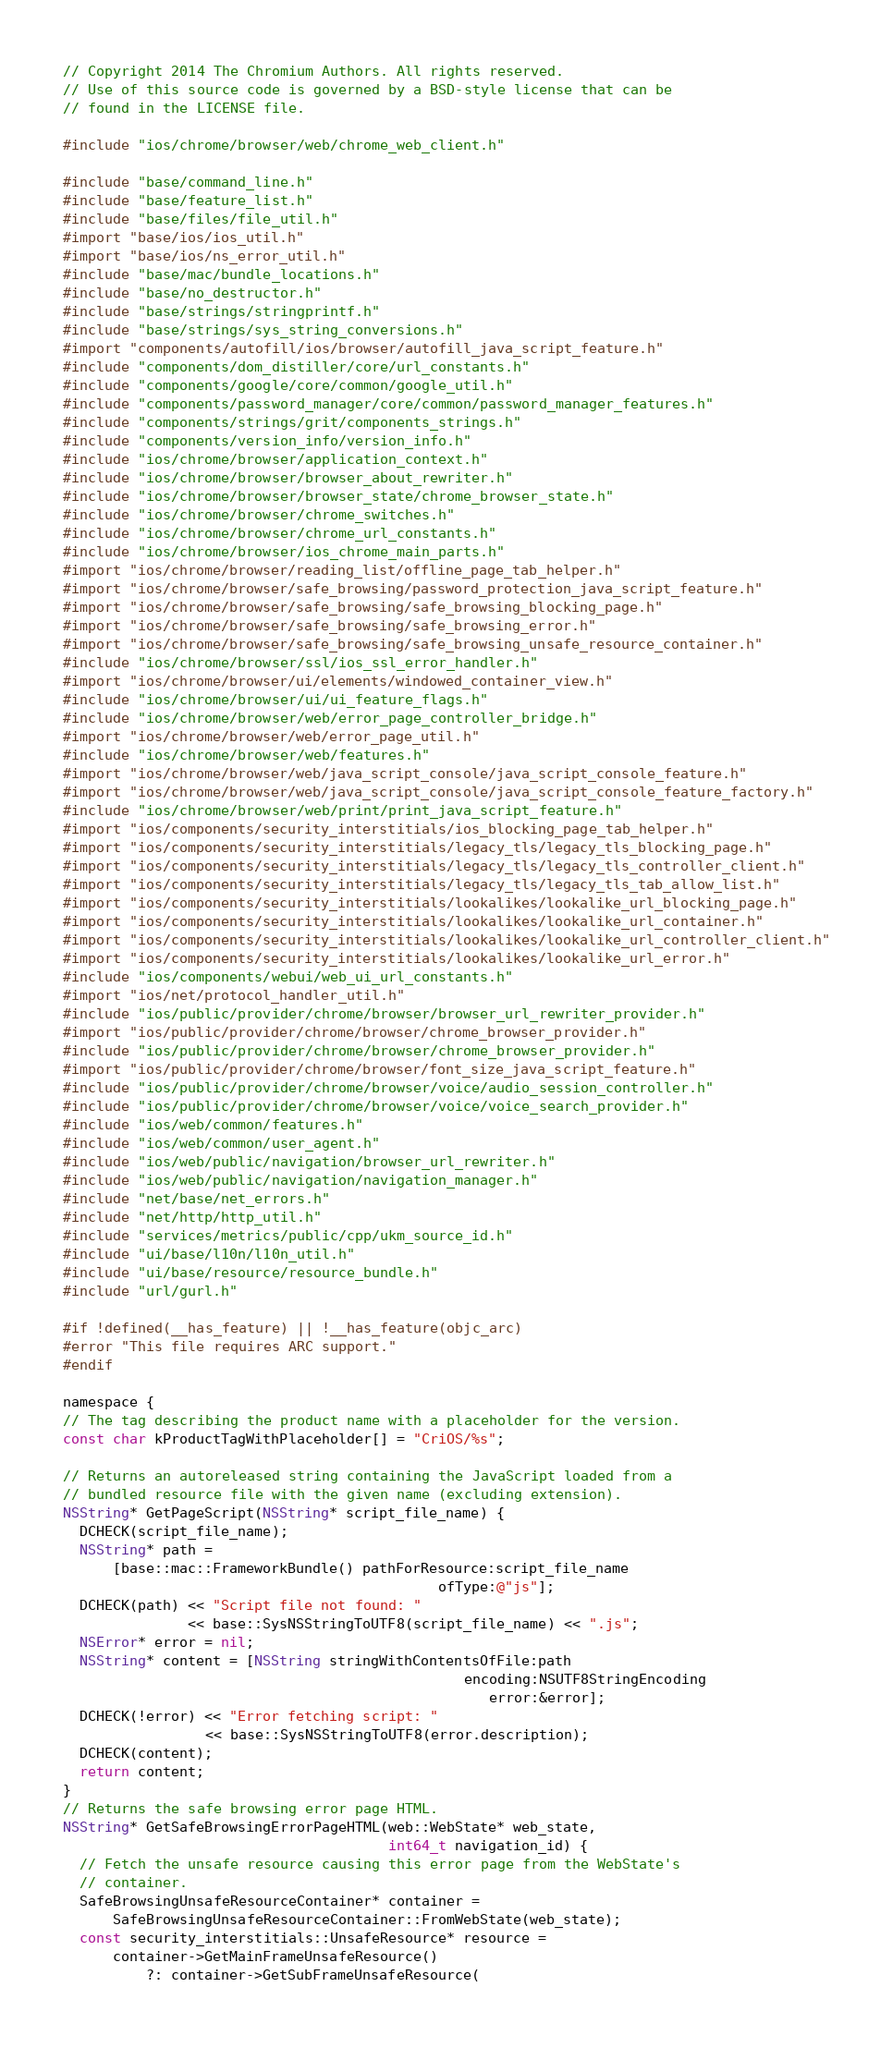Convert code to text. <code><loc_0><loc_0><loc_500><loc_500><_ObjectiveC_>// Copyright 2014 The Chromium Authors. All rights reserved.
// Use of this source code is governed by a BSD-style license that can be
// found in the LICENSE file.

#include "ios/chrome/browser/web/chrome_web_client.h"

#include "base/command_line.h"
#include "base/feature_list.h"
#include "base/files/file_util.h"
#import "base/ios/ios_util.h"
#import "base/ios/ns_error_util.h"
#include "base/mac/bundle_locations.h"
#include "base/no_destructor.h"
#include "base/strings/stringprintf.h"
#include "base/strings/sys_string_conversions.h"
#import "components/autofill/ios/browser/autofill_java_script_feature.h"
#include "components/dom_distiller/core/url_constants.h"
#include "components/google/core/common/google_util.h"
#include "components/password_manager/core/common/password_manager_features.h"
#include "components/strings/grit/components_strings.h"
#include "components/version_info/version_info.h"
#include "ios/chrome/browser/application_context.h"
#include "ios/chrome/browser/browser_about_rewriter.h"
#include "ios/chrome/browser/browser_state/chrome_browser_state.h"
#include "ios/chrome/browser/chrome_switches.h"
#include "ios/chrome/browser/chrome_url_constants.h"
#include "ios/chrome/browser/ios_chrome_main_parts.h"
#import "ios/chrome/browser/reading_list/offline_page_tab_helper.h"
#import "ios/chrome/browser/safe_browsing/password_protection_java_script_feature.h"
#import "ios/chrome/browser/safe_browsing/safe_browsing_blocking_page.h"
#import "ios/chrome/browser/safe_browsing/safe_browsing_error.h"
#import "ios/chrome/browser/safe_browsing/safe_browsing_unsafe_resource_container.h"
#include "ios/chrome/browser/ssl/ios_ssl_error_handler.h"
#import "ios/chrome/browser/ui/elements/windowed_container_view.h"
#include "ios/chrome/browser/ui/ui_feature_flags.h"
#include "ios/chrome/browser/web/error_page_controller_bridge.h"
#import "ios/chrome/browser/web/error_page_util.h"
#include "ios/chrome/browser/web/features.h"
#import "ios/chrome/browser/web/java_script_console/java_script_console_feature.h"
#import "ios/chrome/browser/web/java_script_console/java_script_console_feature_factory.h"
#include "ios/chrome/browser/web/print/print_java_script_feature.h"
#import "ios/components/security_interstitials/ios_blocking_page_tab_helper.h"
#import "ios/components/security_interstitials/legacy_tls/legacy_tls_blocking_page.h"
#import "ios/components/security_interstitials/legacy_tls/legacy_tls_controller_client.h"
#import "ios/components/security_interstitials/legacy_tls/legacy_tls_tab_allow_list.h"
#import "ios/components/security_interstitials/lookalikes/lookalike_url_blocking_page.h"
#import "ios/components/security_interstitials/lookalikes/lookalike_url_container.h"
#import "ios/components/security_interstitials/lookalikes/lookalike_url_controller_client.h"
#import "ios/components/security_interstitials/lookalikes/lookalike_url_error.h"
#include "ios/components/webui/web_ui_url_constants.h"
#import "ios/net/protocol_handler_util.h"
#include "ios/public/provider/chrome/browser/browser_url_rewriter_provider.h"
#import "ios/public/provider/chrome/browser/chrome_browser_provider.h"
#include "ios/public/provider/chrome/browser/chrome_browser_provider.h"
#import "ios/public/provider/chrome/browser/font_size_java_script_feature.h"
#include "ios/public/provider/chrome/browser/voice/audio_session_controller.h"
#include "ios/public/provider/chrome/browser/voice/voice_search_provider.h"
#include "ios/web/common/features.h"
#include "ios/web/common/user_agent.h"
#include "ios/web/public/navigation/browser_url_rewriter.h"
#include "ios/web/public/navigation/navigation_manager.h"
#include "net/base/net_errors.h"
#include "net/http/http_util.h"
#include "services/metrics/public/cpp/ukm_source_id.h"
#include "ui/base/l10n/l10n_util.h"
#include "ui/base/resource/resource_bundle.h"
#include "url/gurl.h"

#if !defined(__has_feature) || !__has_feature(objc_arc)
#error "This file requires ARC support."
#endif

namespace {
// The tag describing the product name with a placeholder for the version.
const char kProductTagWithPlaceholder[] = "CriOS/%s";

// Returns an autoreleased string containing the JavaScript loaded from a
// bundled resource file with the given name (excluding extension).
NSString* GetPageScript(NSString* script_file_name) {
  DCHECK(script_file_name);
  NSString* path =
      [base::mac::FrameworkBundle() pathForResource:script_file_name
                                             ofType:@"js"];
  DCHECK(path) << "Script file not found: "
               << base::SysNSStringToUTF8(script_file_name) << ".js";
  NSError* error = nil;
  NSString* content = [NSString stringWithContentsOfFile:path
                                                encoding:NSUTF8StringEncoding
                                                   error:&error];
  DCHECK(!error) << "Error fetching script: "
                 << base::SysNSStringToUTF8(error.description);
  DCHECK(content);
  return content;
}
// Returns the safe browsing error page HTML.
NSString* GetSafeBrowsingErrorPageHTML(web::WebState* web_state,
                                       int64_t navigation_id) {
  // Fetch the unsafe resource causing this error page from the WebState's
  // container.
  SafeBrowsingUnsafeResourceContainer* container =
      SafeBrowsingUnsafeResourceContainer::FromWebState(web_state);
  const security_interstitials::UnsafeResource* resource =
      container->GetMainFrameUnsafeResource()
          ?: container->GetSubFrameUnsafeResource(</code> 